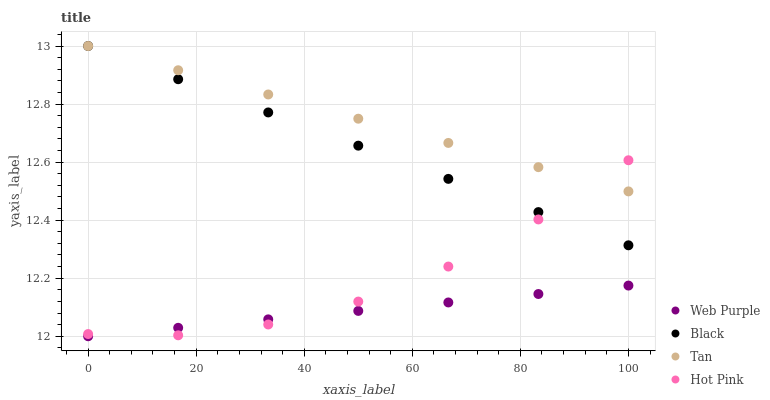Does Web Purple have the minimum area under the curve?
Answer yes or no. Yes. Does Tan have the maximum area under the curve?
Answer yes or no. Yes. Does Hot Pink have the minimum area under the curve?
Answer yes or no. No. Does Hot Pink have the maximum area under the curve?
Answer yes or no. No. Is Black the smoothest?
Answer yes or no. Yes. Is Hot Pink the roughest?
Answer yes or no. Yes. Is Hot Pink the smoothest?
Answer yes or no. No. Is Black the roughest?
Answer yes or no. No. Does Web Purple have the lowest value?
Answer yes or no. Yes. Does Hot Pink have the lowest value?
Answer yes or no. No. Does Tan have the highest value?
Answer yes or no. Yes. Does Hot Pink have the highest value?
Answer yes or no. No. Is Web Purple less than Black?
Answer yes or no. Yes. Is Tan greater than Web Purple?
Answer yes or no. Yes. Does Black intersect Hot Pink?
Answer yes or no. Yes. Is Black less than Hot Pink?
Answer yes or no. No. Is Black greater than Hot Pink?
Answer yes or no. No. Does Web Purple intersect Black?
Answer yes or no. No. 